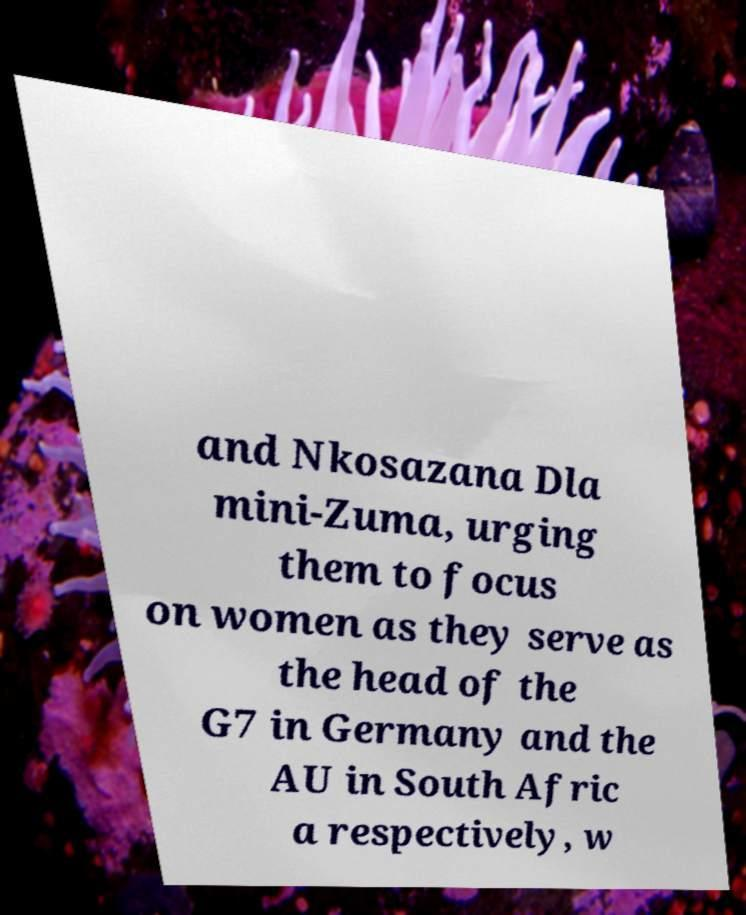Please identify and transcribe the text found in this image. and Nkosazana Dla mini-Zuma, urging them to focus on women as they serve as the head of the G7 in Germany and the AU in South Afric a respectively, w 